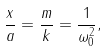<formula> <loc_0><loc_0><loc_500><loc_500>\frac { x } { a } = \frac { m } { k } = \frac { 1 } { \omega ^ { 2 } _ { 0 } } ,</formula> 